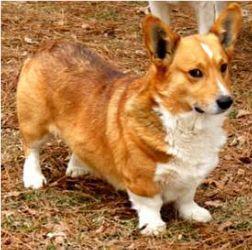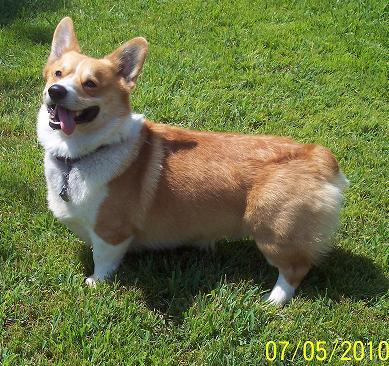The first image is the image on the left, the second image is the image on the right. Examine the images to the left and right. Is the description "A dog is stationary with their tongue hanging out." accurate? Answer yes or no. Yes. The first image is the image on the left, the second image is the image on the right. For the images shown, is this caption "At least one dog is sitting." true? Answer yes or no. No. 